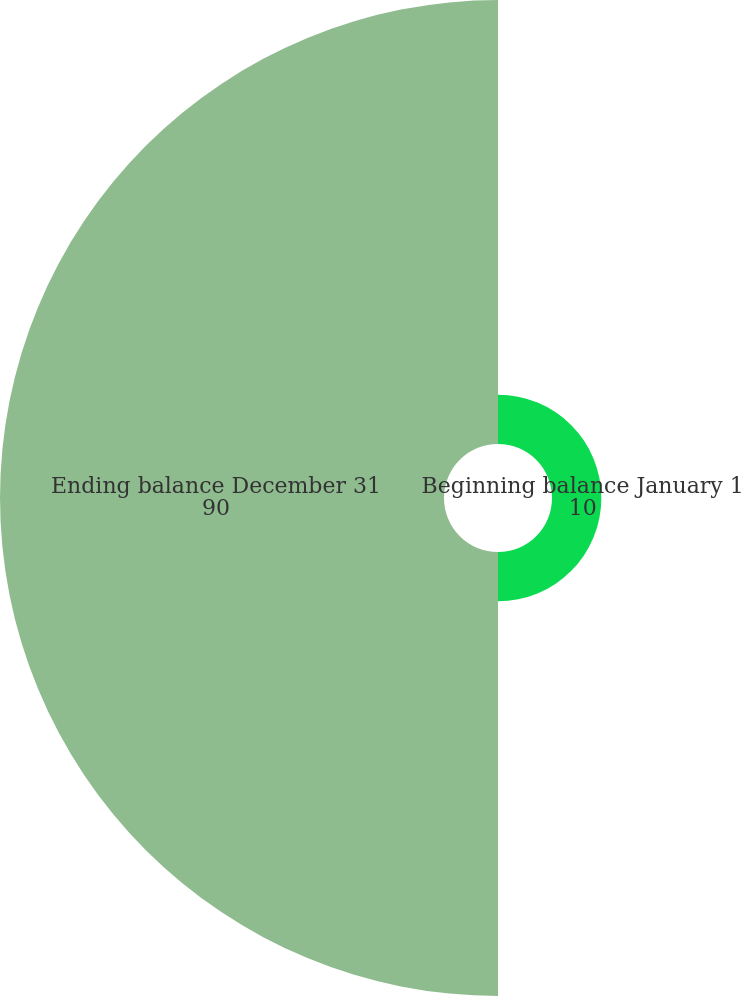Convert chart. <chart><loc_0><loc_0><loc_500><loc_500><pie_chart><fcel>Beginning balance January 1<fcel>Ending balance December 31<nl><fcel>10.0%<fcel>90.0%<nl></chart> 